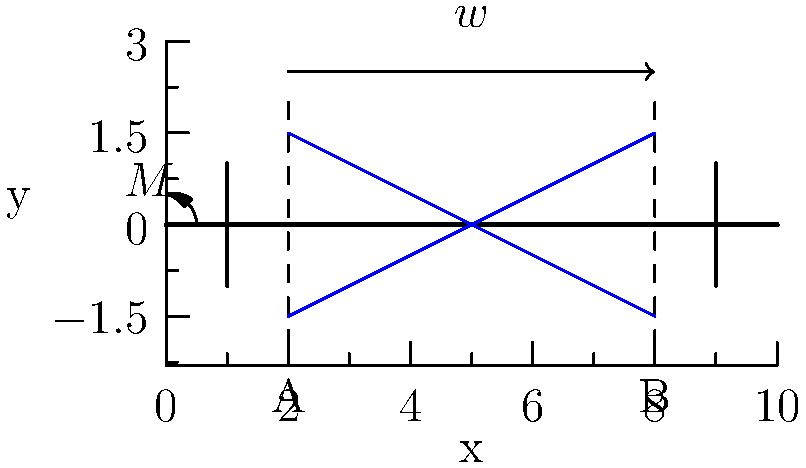In a simply supported beam subjected to a uniformly distributed load $w$ and an end moment $M$ as shown, how does the stress distribution vary between points A and B? Consider both normal and shear stresses in your analysis. To analyze the stress distribution between points A and B, we need to consider both normal and shear stresses:

1. Normal stress distribution:
   a) Due to bending moment:
      - The bending moment varies along the beam, increasing from left to right.
      - At any cross-section, the normal stress follows a linear distribution, with maximum tension at the top and maximum compression at the bottom.
      - The magnitude of normal stress increases from A to B due to increasing bending moment.
   
   b) Due to end moment M:
      - The end moment creates additional normal stress, constant along the beam length.
      - This stress is superimposed on the bending stress.

2. Shear stress distribution:
   - Shear stress is caused by the vertical shear force.
   - For a rectangular cross-section, the shear stress distribution is parabolic, with maximum at the neutral axis and zero at the top and bottom surfaces.
   - The shear stress magnitude decreases from A to B as the shear force decreases.

3. Combined stress state:
   - The normal stress dominates near the top and bottom surfaces.
   - The shear stress is most significant near the neutral axis.
   - The principal stresses (maximum and minimum normal stresses) occur at an angle to the beam axis, varying along the length and through the depth of the beam.

4. Variation from A to B:
   - Normal stress magnitude increases.
   - Shear stress magnitude decreases.
   - The ratio of normal to shear stress increases, affecting the direction of principal stresses.

In summary, the stress distribution between A and B is complex, with normal stress increasing and shear stress decreasing, resulting in a varying state of combined stress along the beam.
Answer: Normal stress increases, shear stress decreases from A to B; combined stress state varies along beam length and depth. 